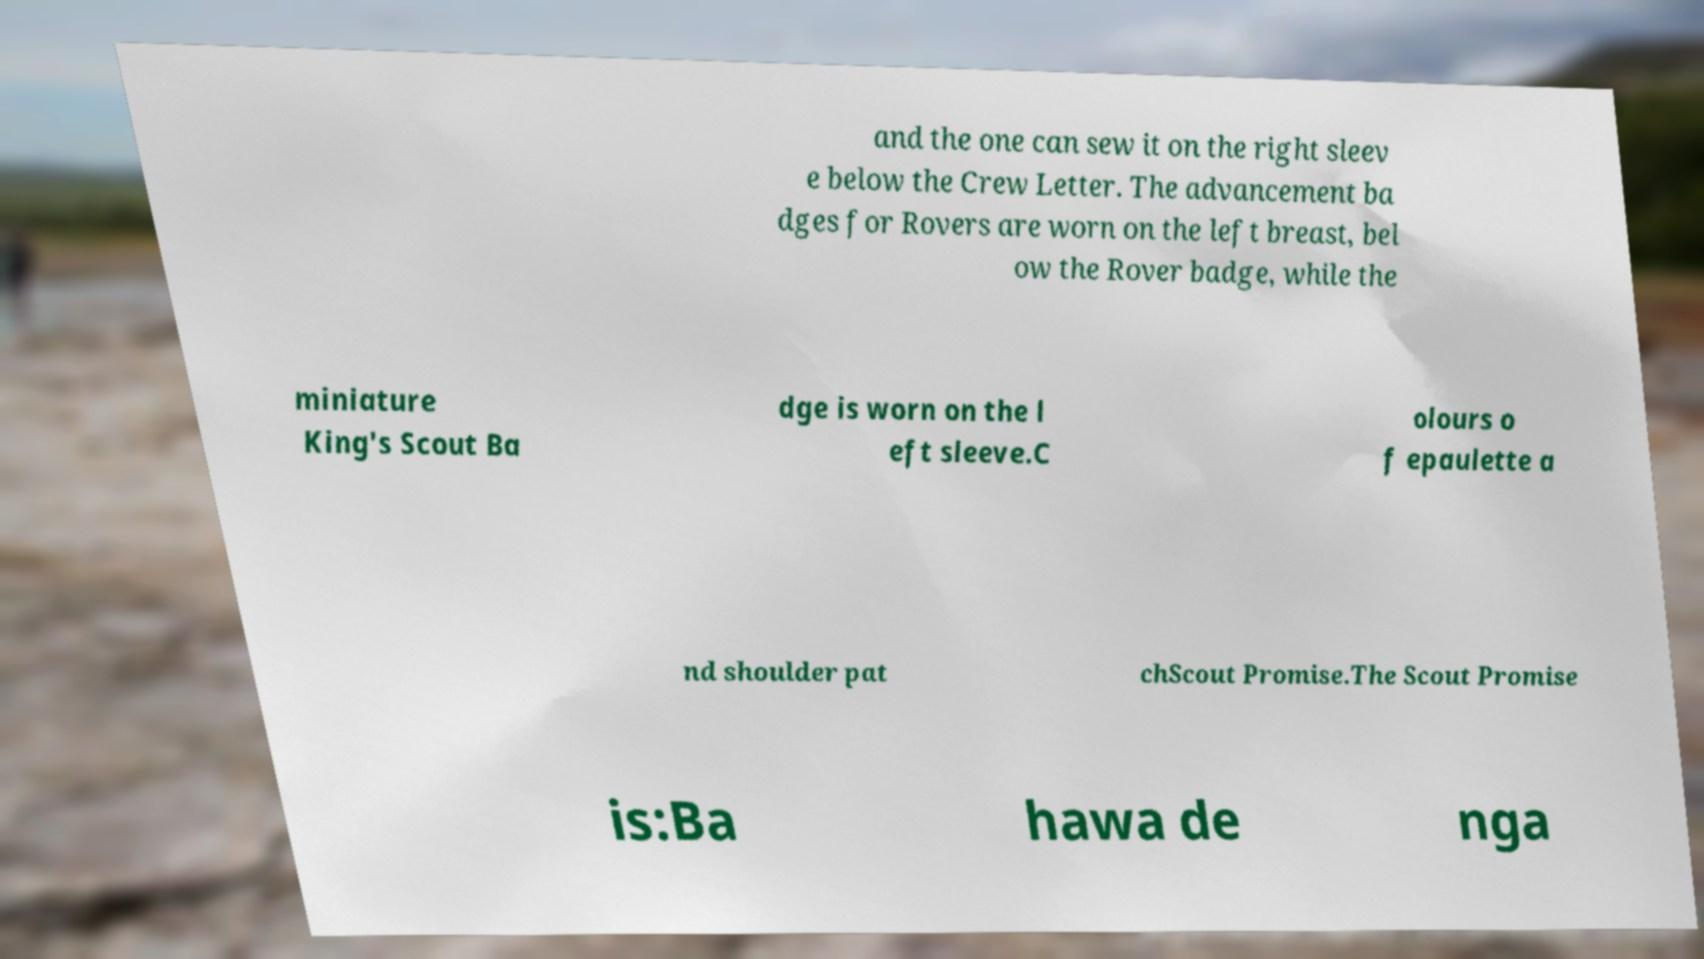What messages or text are displayed in this image? I need them in a readable, typed format. and the one can sew it on the right sleev e below the Crew Letter. The advancement ba dges for Rovers are worn on the left breast, bel ow the Rover badge, while the miniature King's Scout Ba dge is worn on the l eft sleeve.C olours o f epaulette a nd shoulder pat chScout Promise.The Scout Promise is:Ba hawa de nga 